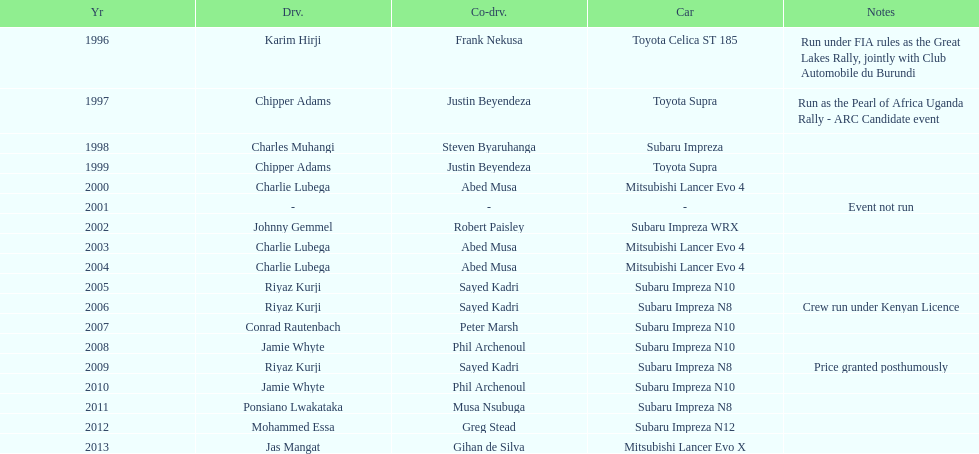Do chipper adams and justin beyendeza have more than 3 wins? No. 